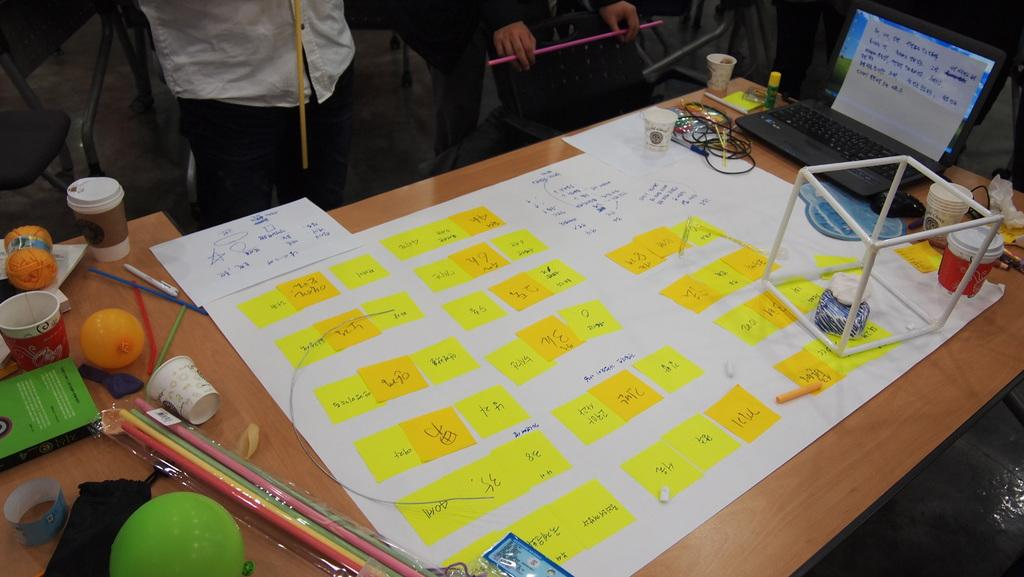What type of visual representation is in the image? There is a chart in the image. What is the small, colorful object in the image? There is a chup in the image. What decorative items can be seen in the image? There are balloons in the image. What writing instrument is present in the image? There is a pen in the image. What electronic device is in the image? There is a laptop in the image. What is the thin, flexible object on the table in the image? There is a wire on the table in the image. Who is present in the image? There are people standing in the image. How many hours are visible in the image? There is no reference to hours or time in the image. What color are the eyes of the person in the image? There is no person's eyes visible in the image. How does the laptop move around in the image? The laptop does not move around in the image; it is stationary on the table. 